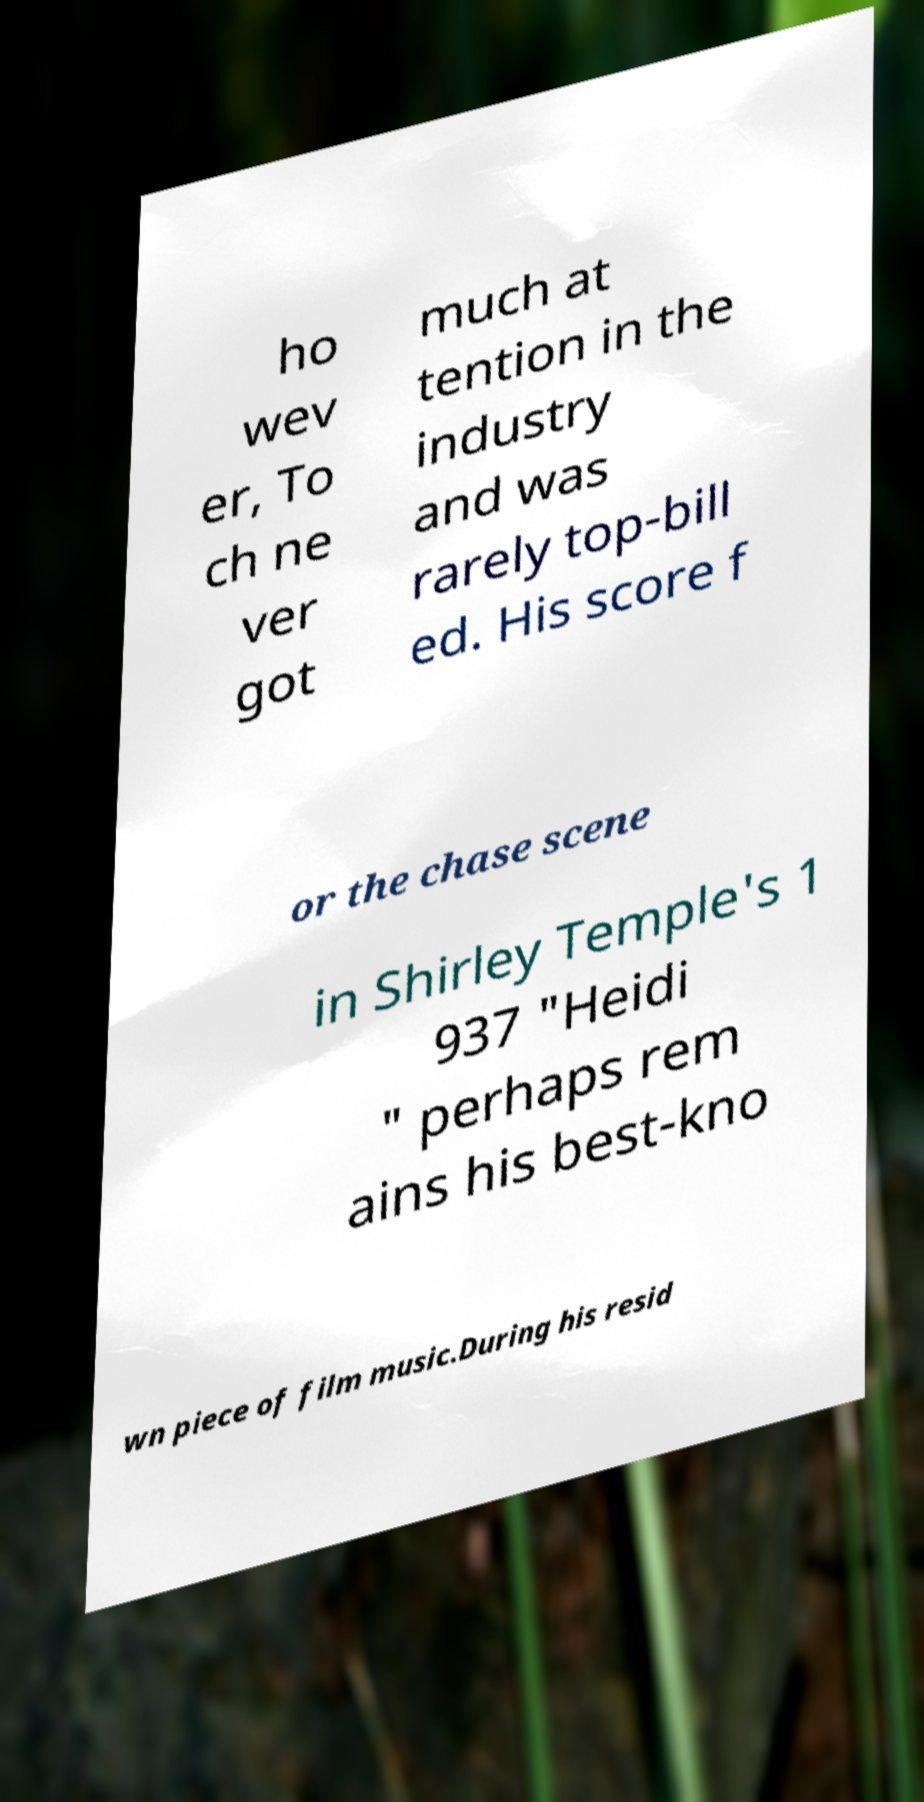Please identify and transcribe the text found in this image. ho wev er, To ch ne ver got much at tention in the industry and was rarely top-bill ed. His score f or the chase scene in Shirley Temple's 1 937 "Heidi " perhaps rem ains his best-kno wn piece of film music.During his resid 